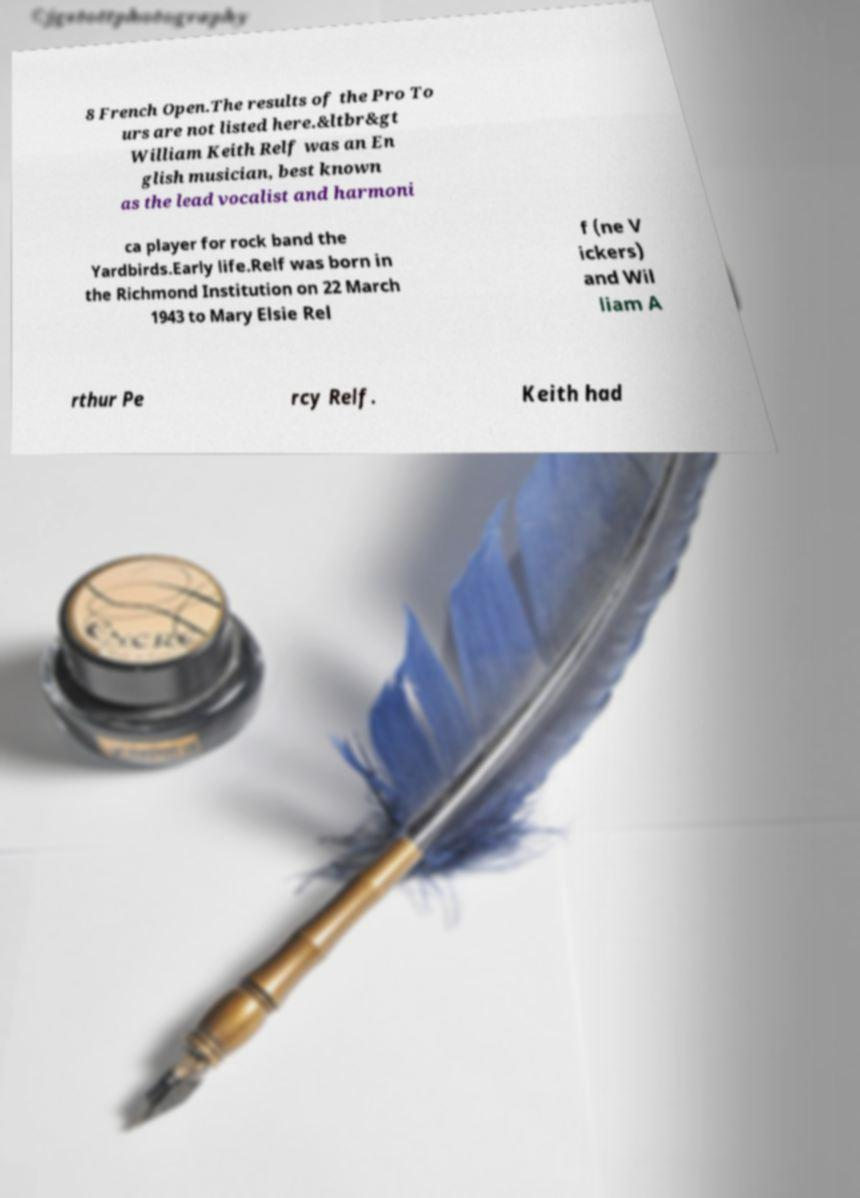Could you extract and type out the text from this image? 8 French Open.The results of the Pro To urs are not listed here.&ltbr&gt William Keith Relf was an En glish musician, best known as the lead vocalist and harmoni ca player for rock band the Yardbirds.Early life.Relf was born in the Richmond Institution on 22 March 1943 to Mary Elsie Rel f (ne V ickers) and Wil liam A rthur Pe rcy Relf. Keith had 